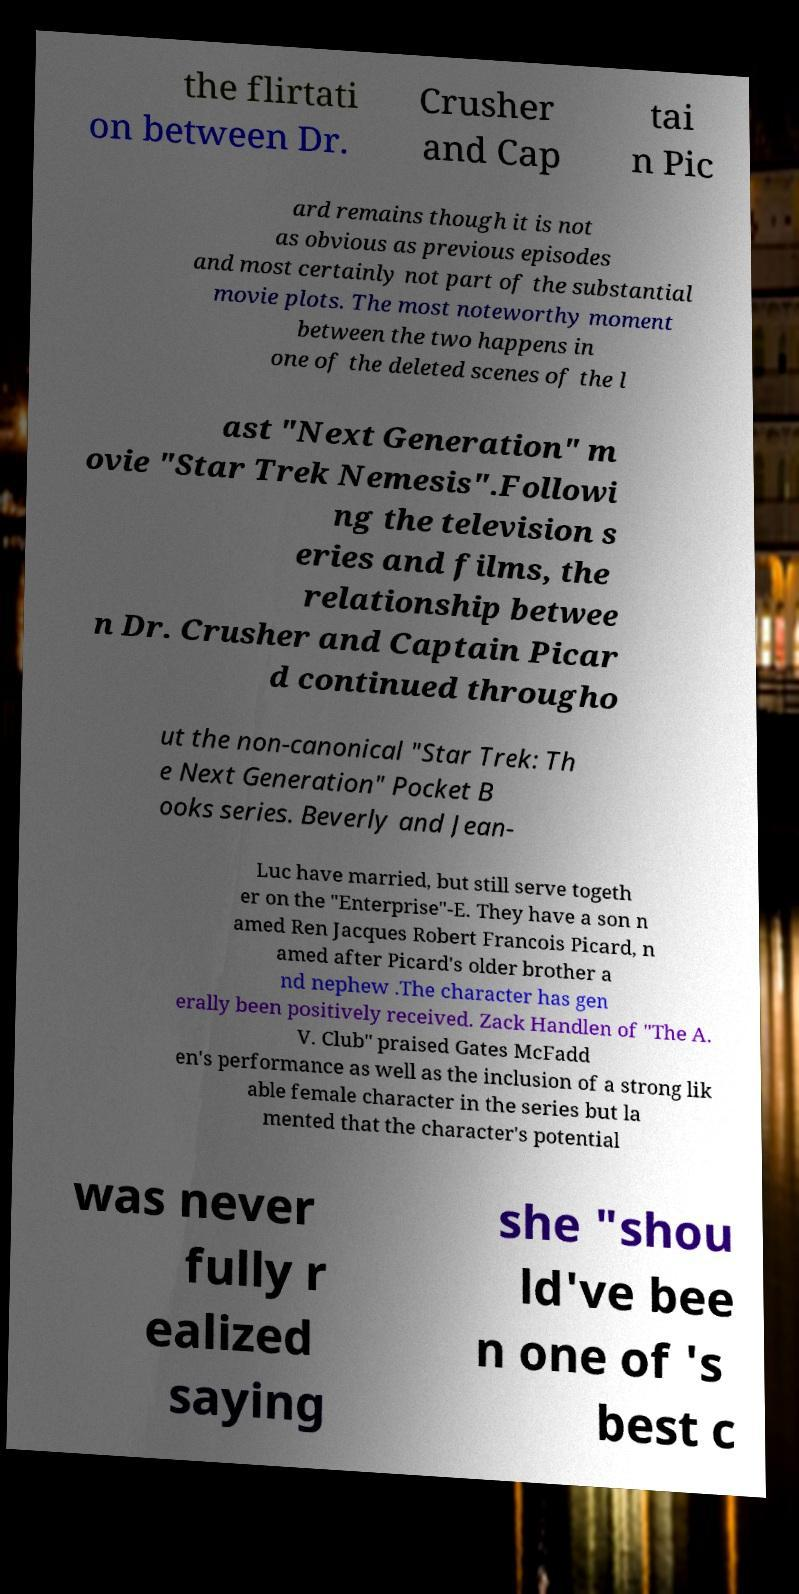Please read and relay the text visible in this image. What does it say? the flirtati on between Dr. Crusher and Cap tai n Pic ard remains though it is not as obvious as previous episodes and most certainly not part of the substantial movie plots. The most noteworthy moment between the two happens in one of the deleted scenes of the l ast "Next Generation" m ovie "Star Trek Nemesis".Followi ng the television s eries and films, the relationship betwee n Dr. Crusher and Captain Picar d continued througho ut the non-canonical "Star Trek: Th e Next Generation" Pocket B ooks series. Beverly and Jean- Luc have married, but still serve togeth er on the "Enterprise"-E. They have a son n amed Ren Jacques Robert Francois Picard, n amed after Picard's older brother a nd nephew .The character has gen erally been positively received. Zack Handlen of "The A. V. Club" praised Gates McFadd en's performance as well as the inclusion of a strong lik able female character in the series but la mented that the character's potential was never fully r ealized saying she "shou ld've bee n one of 's best c 